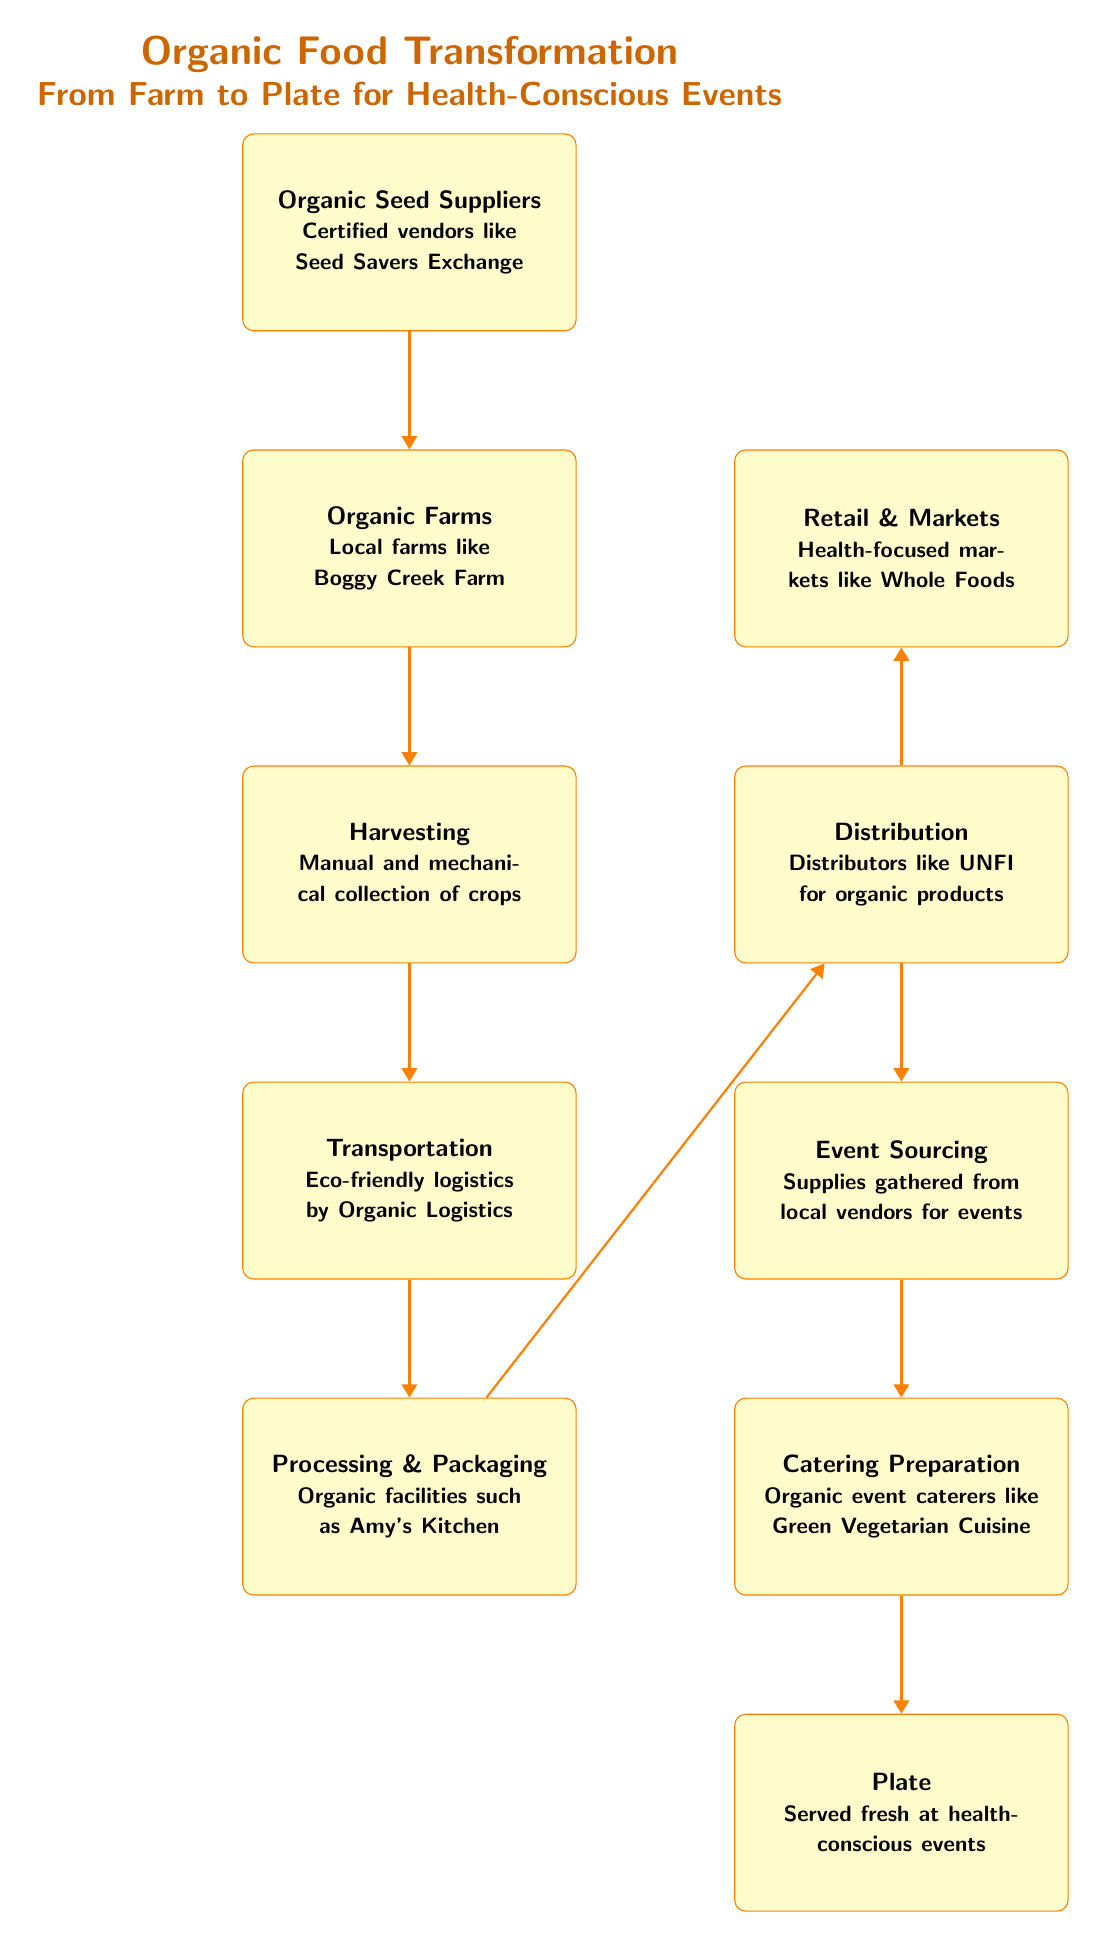What is the first node in the diagram? The diagram starts with "Organic Seed Suppliers," which is the topmost node, indicating it as the first step in the food chain.
Answer: Organic Seed Suppliers How many steps are there from farm to plate? By counting the nodes from "Organic Seed Suppliers" to "Plate," there are a total of seven steps (nodes) in this transformation process.
Answer: 7 Which node represents the distribution process? The "Distribution" node is present on the right side of the diagram, indicating where the distribution of organic products occurs.
Answer: Distribution What kind of farms are mentioned in the diagram? The diagram refers to "Local farms like Boggy Creek Farm" as examples of the type of organic farms involved in food transformation.
Answer: Local farms like Boggy Creek Farm Which node comes after "Transportation"? According to the flow from "Transportation," the next node is "Processing & Packaging," illustrating the sequence in the food chain.
Answer: Processing & Packaging What type of vendors are involved at the "Event Sourcing" stage? The "Event Sourcing" stage involves "local vendors," indicating that local sources are used to gather supplies for the events.
Answer: Local vendors Which node handles the final presentation of food? The "Plate" node signifies the final stage in the food chain, where the food is served at health-conscious events.
Answer: Plate What is the relationship between "Processing & Packaging" and "Distribution"? The "Processing & Packaging" node feeds directly into the "Distribution" node, showing that processed and packaged organic food is then distributed to markets.
Answer: Direct flow Which entity is responsible for eco-friendly logistics? The "Transportation" node specifies "Eco-friendly logistics by Organic Logistics," indicating the entity responsible for ensuring sustainability in transportation.
Answer: Eco-friendly logistics by Organic Logistics 